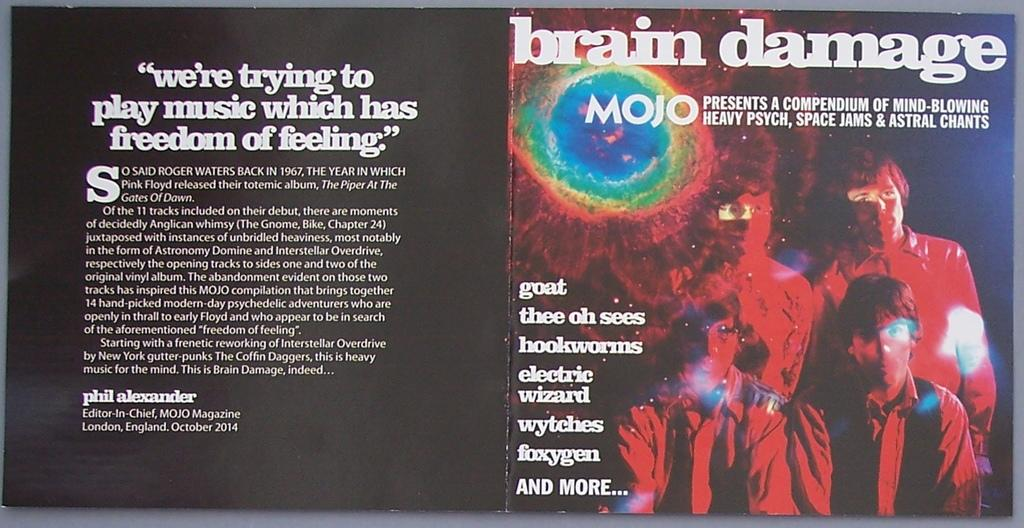<image>
Give a short and clear explanation of the subsequent image. An open book with the title brain damage and a photo of four men 